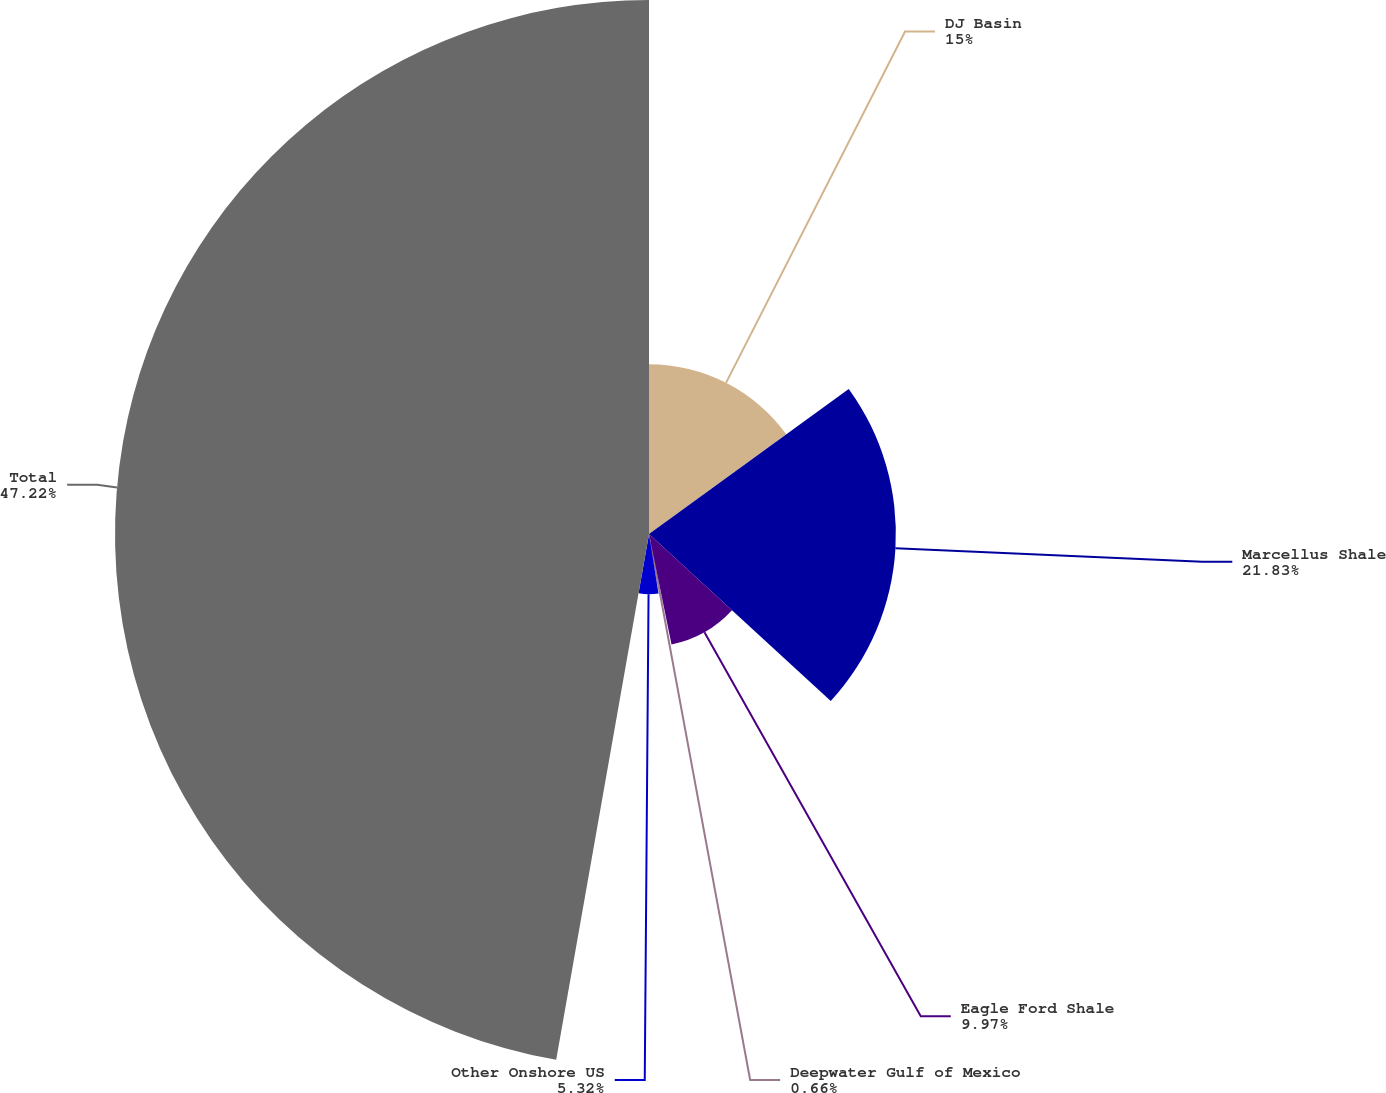Convert chart. <chart><loc_0><loc_0><loc_500><loc_500><pie_chart><fcel>DJ Basin<fcel>Marcellus Shale<fcel>Eagle Ford Shale<fcel>Deepwater Gulf of Mexico<fcel>Other Onshore US<fcel>Total<nl><fcel>15.0%<fcel>21.83%<fcel>9.97%<fcel>0.66%<fcel>5.32%<fcel>47.22%<nl></chart> 